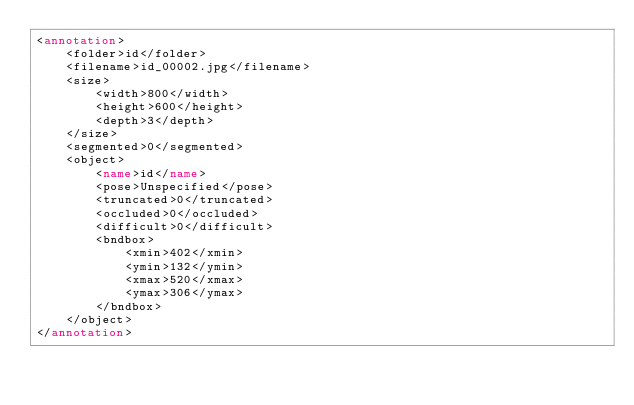Convert code to text. <code><loc_0><loc_0><loc_500><loc_500><_XML_><annotation>
    <folder>id</folder>
    <filename>id_00002.jpg</filename>
    <size>
        <width>800</width>
        <height>600</height>
        <depth>3</depth>
    </size>
    <segmented>0</segmented>
    <object>
        <name>id</name>
        <pose>Unspecified</pose>
        <truncated>0</truncated>
        <occluded>0</occluded>
        <difficult>0</difficult>
        <bndbox>
            <xmin>402</xmin>
            <ymin>132</ymin>
            <xmax>520</xmax>
            <ymax>306</ymax>
        </bndbox>
    </object>
</annotation></code> 